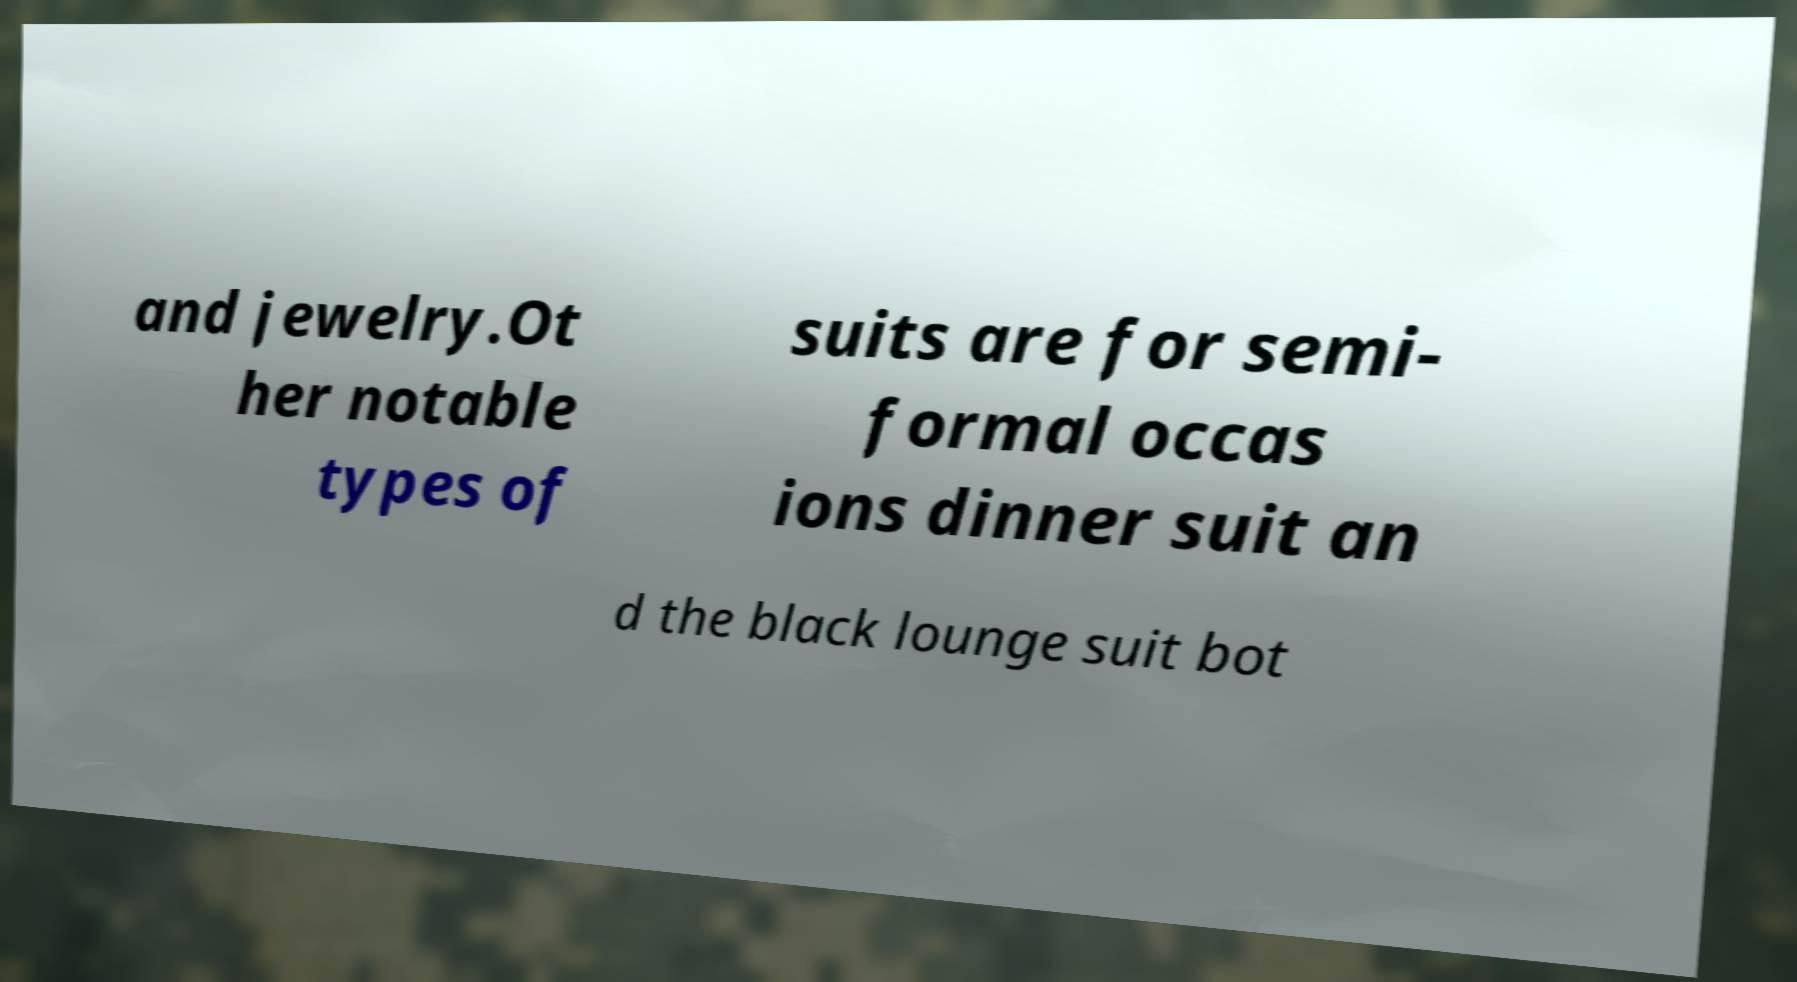Could you assist in decoding the text presented in this image and type it out clearly? and jewelry.Ot her notable types of suits are for semi- formal occas ions dinner suit an d the black lounge suit bot 